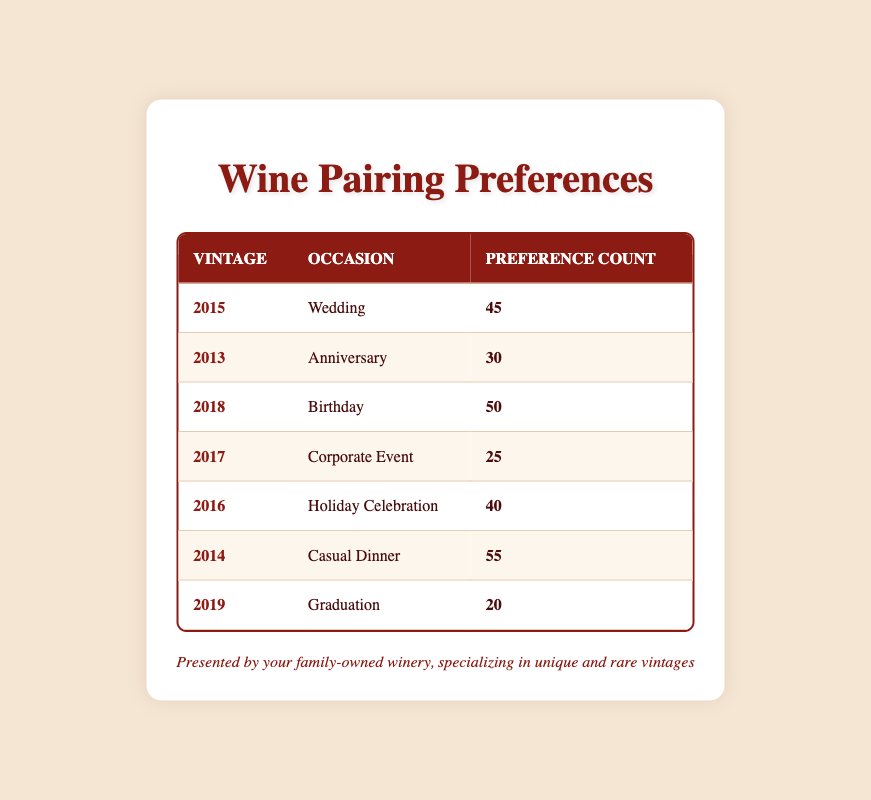What is the preference count for the 2016 vintage during Holiday Celebration? The table shows a specific row for the 2016 vintage paired with the occasion of Holiday Celebration, where the preference count listed is 40.
Answer: 40 Which vintage has the highest preference count and what is that count? Scanning through the table, the vintage with the highest preference count is 2014, which has a count of 55 for the occasion of Casual Dinner.
Answer: 55 What is the total preference count for occasions related to celebrations (Wedding, Birthday, Holiday Celebration)? Adding the preference counts for Wedding (45), Birthday (50), and Holiday Celebration (40) gives us a total of 135 (45 + 50 + 40 = 135).
Answer: 135 Is there a trend that shows older vintages are preferred for significant occasions like Weddings or Anniversaries? Yes, Wedding (2015) and Anniversary (2013) both have significantly high preference counts, indicating a trend where older vintages are preferred for significant occasions.
Answer: Yes What is the average preference count for the vintages listed? To calculate the average, sum all preference counts (45 + 30 + 50 + 25 + 40 + 55 + 20 = 265) and divide by the number of vintages (7). This results in an average of approximately 37.86 (265/7 ≈ 37.86).
Answer: 37.86 Which occasion had the lowest preference count and what was that count? By scanning the table, the Graduation occasion for the vintage of 2019 had the lowest preference count, listed as 20.
Answer: 20 What is the preference difference between the most preferred occasion (Casual Dinner) and the least preferred occasion (Graduation)? The most preferred occasion is Casual Dinner with a count of 55, and the least preferred is Graduation with a count of 20. The difference is 35 (55 - 20 = 35).
Answer: 35 Are there any occasions where the preference count is above 50? Yes, both the Casual Dinner (55) and Birthday (50) occasions have preference counts above 50.
Answer: Yes Which vintage is paired with Corporate Event and how many preferences does it have? The Corporate Event is paired with the 2017 vintage, which has a preference count of 25 listed in the table.
Answer: 25 